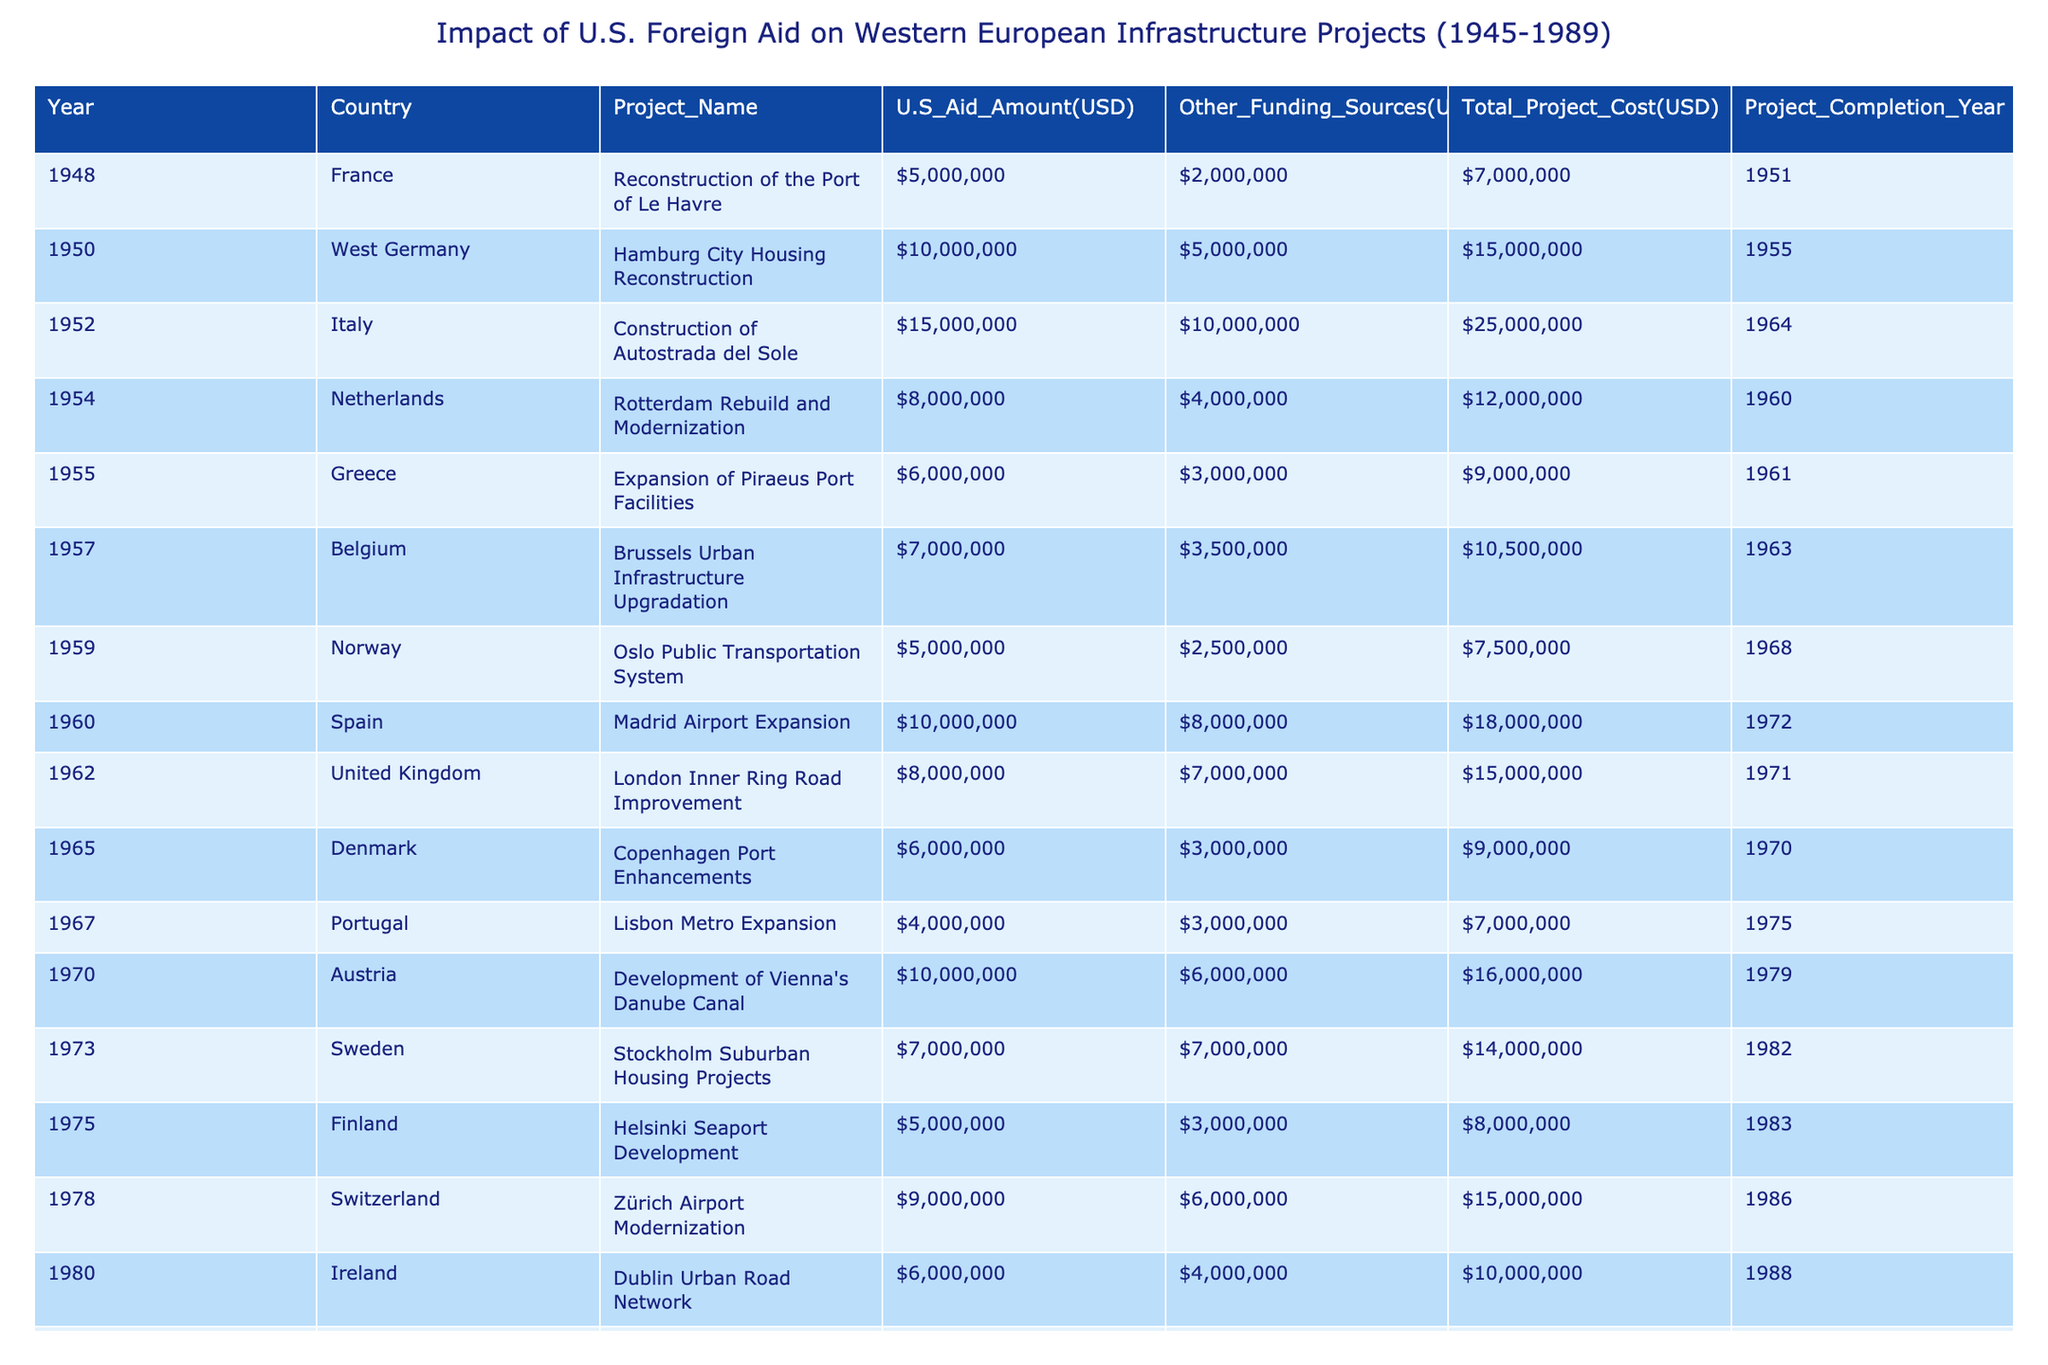What was the U.S. aid amount for the project in France in 1948? The table shows that in 1948, the U.S. aid amount for the "Reconstruction of the Port of Le Havre" in France was 5,000,000 USD.
Answer: 5,000,000 USD Which project had the highest total project cost? By analyzing the 'Total Project Cost' column, it is evident that the "Construction of Autostrada del Sole" in Italy had the highest total project cost of 25,000,000 USD.
Answer: 25,000,000 USD Did the Netherlands receive more U.S. aid than Greece for their respective projects? The table indicates that the U.S. aid for the "Rotterdam Rebuild and Modernization" in the Netherlands was 8,000,000 USD, while Greece received 6,000,000 USD for the "Expansion of Piraeus Port Facilities." Therefore, the Netherlands received more aid.
Answer: Yes What is the average U.S. aid amount across all projects listed in the table? To calculate the average U.S. aid amount, first sum the U.S. aid amounts: 5,000,000 + 10,000,000 + 15,000,000 + 8,000,000 + 6,000,000 + 7,000,000 + 5,000,000 + 10,000,000 + 8,000,000 + 6,000,000 + 4,000,000 + 10,000,000 + 7,000,000 + 5,000,000 + 9,000,000 + 6,000,000 + 4,000,000 + 3,000,000 = 139,000,000 USD. There are 17 projects in total, so the average is 139,000,000 / 17 ≈ 8,176,471 USD.
Answer: Approximately 8,176,471 USD Which country’s project involved the lowest amount of U.S. aid? By examining the U.S. aid amounts, it can be determined that Iceland received the lowest U.S. aid amount of 3,000,000 USD for the "Reykjavik Geothermal Energy Plants."
Answer: 3,000,000 USD What is the total funding from other sources for the project in Sweden? From the table, the "Stockholm Suburban Housing Projects" in Sweden received 7,000,000 USD from other funding sources.
Answer: 7,000,000 USD Which project had a total cost of over 15 million USD and was completed in the 1970s? Looking at the 'Total Project Cost' and 'Project Completion Year' columns, the "Development of Vienna's Danube Canal" in Austria, completed in 1979 for 16,000,000 USD, fits these criteria.
Answer: Development of Vienna's Danube Canal What was the combined total project cost of the infrastructure projects completed in the 1960s? To calculate this, sum the total project costs of projects completed between 1960 and 1969: Rotterdam Rebuild and Modernization (12,000,000) + Madrid Airport Expansion (18,000,000) + London Inner Ring Road Improvement (15,000,000) + Lisbon Metro Expansion (7,000,000) = 52,000,000 USD.
Answer: 52,000,000 USD 